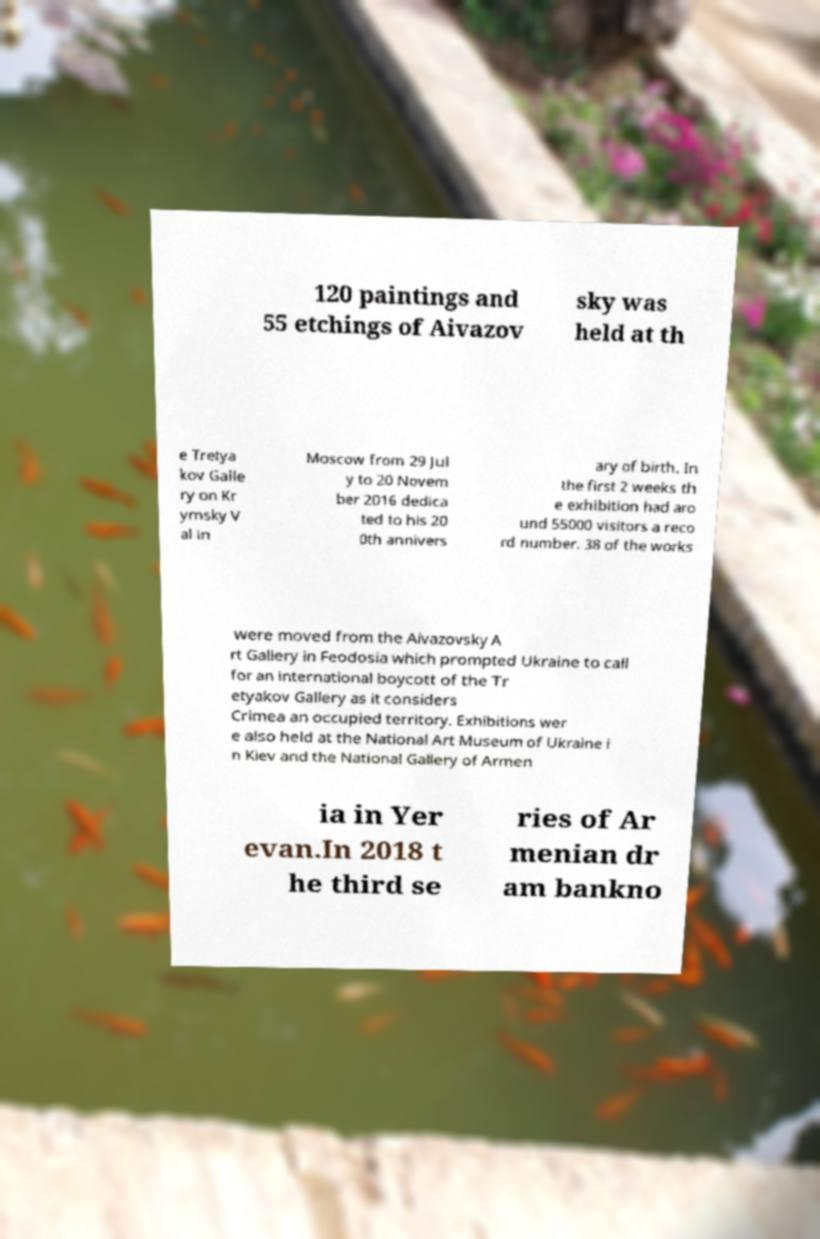I need the written content from this picture converted into text. Can you do that? 120 paintings and 55 etchings of Aivazov sky was held at th e Tretya kov Galle ry on Kr ymsky V al in Moscow from 29 Jul y to 20 Novem ber 2016 dedica ted to his 20 0th annivers ary of birth. In the first 2 weeks th e exhibition had aro und 55000 visitors a reco rd number. 38 of the works were moved from the Aivazovsky A rt Gallery in Feodosia which prompted Ukraine to call for an international boycott of the Tr etyakov Gallery as it considers Crimea an occupied territory. Exhibitions wer e also held at the National Art Museum of Ukraine i n Kiev and the National Gallery of Armen ia in Yer evan.In 2018 t he third se ries of Ar menian dr am bankno 